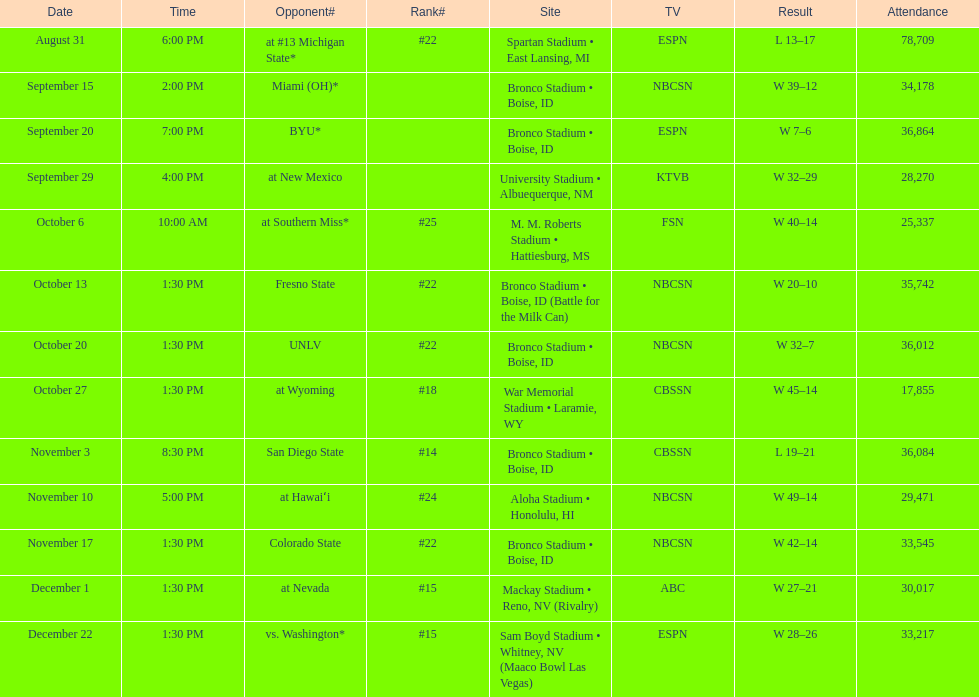How many points did miami (oh) score against the broncos? 12. 